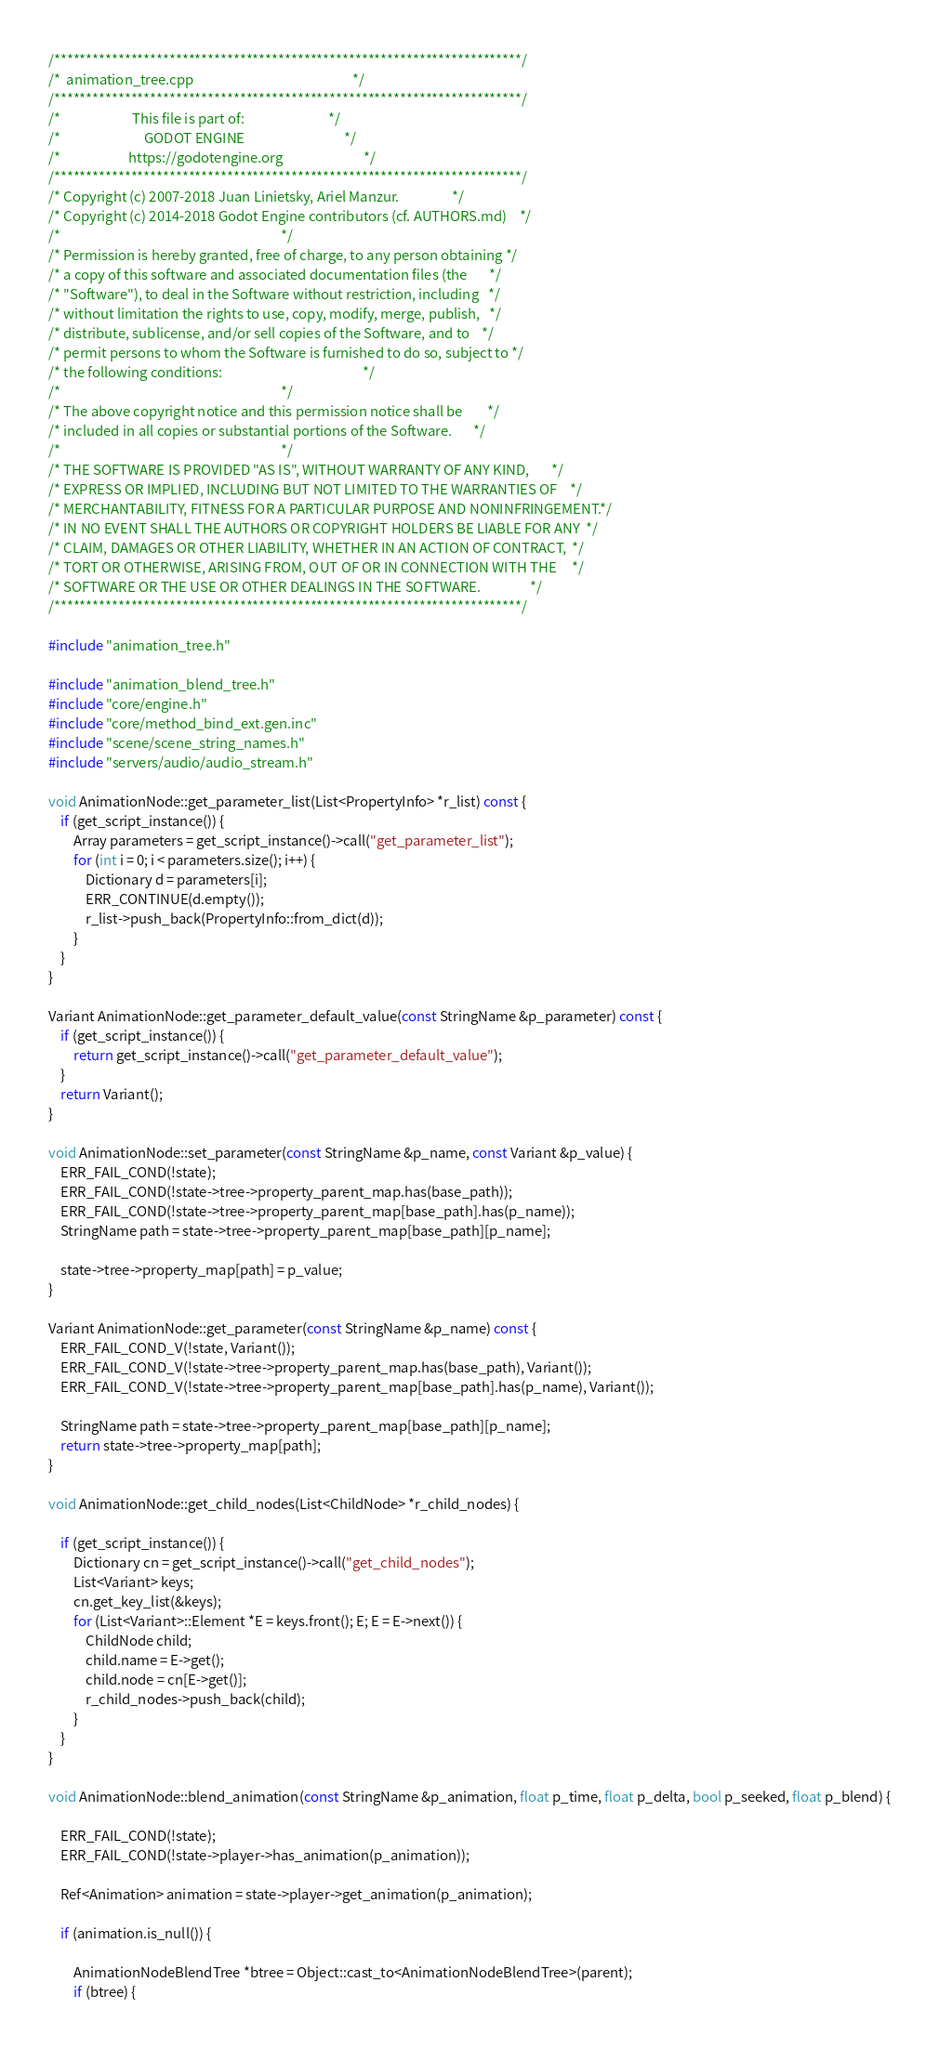<code> <loc_0><loc_0><loc_500><loc_500><_C++_>/*************************************************************************/
/*  animation_tree.cpp                                                   */
/*************************************************************************/
/*                       This file is part of:                           */
/*                           GODOT ENGINE                                */
/*                      https://godotengine.org                          */
/*************************************************************************/
/* Copyright (c) 2007-2018 Juan Linietsky, Ariel Manzur.                 */
/* Copyright (c) 2014-2018 Godot Engine contributors (cf. AUTHORS.md)    */
/*                                                                       */
/* Permission is hereby granted, free of charge, to any person obtaining */
/* a copy of this software and associated documentation files (the       */
/* "Software"), to deal in the Software without restriction, including   */
/* without limitation the rights to use, copy, modify, merge, publish,   */
/* distribute, sublicense, and/or sell copies of the Software, and to    */
/* permit persons to whom the Software is furnished to do so, subject to */
/* the following conditions:                                             */
/*                                                                       */
/* The above copyright notice and this permission notice shall be        */
/* included in all copies or substantial portions of the Software.       */
/*                                                                       */
/* THE SOFTWARE IS PROVIDED "AS IS", WITHOUT WARRANTY OF ANY KIND,       */
/* EXPRESS OR IMPLIED, INCLUDING BUT NOT LIMITED TO THE WARRANTIES OF    */
/* MERCHANTABILITY, FITNESS FOR A PARTICULAR PURPOSE AND NONINFRINGEMENT.*/
/* IN NO EVENT SHALL THE AUTHORS OR COPYRIGHT HOLDERS BE LIABLE FOR ANY  */
/* CLAIM, DAMAGES OR OTHER LIABILITY, WHETHER IN AN ACTION OF CONTRACT,  */
/* TORT OR OTHERWISE, ARISING FROM, OUT OF OR IN CONNECTION WITH THE     */
/* SOFTWARE OR THE USE OR OTHER DEALINGS IN THE SOFTWARE.                */
/*************************************************************************/

#include "animation_tree.h"

#include "animation_blend_tree.h"
#include "core/engine.h"
#include "core/method_bind_ext.gen.inc"
#include "scene/scene_string_names.h"
#include "servers/audio/audio_stream.h"

void AnimationNode::get_parameter_list(List<PropertyInfo> *r_list) const {
	if (get_script_instance()) {
		Array parameters = get_script_instance()->call("get_parameter_list");
		for (int i = 0; i < parameters.size(); i++) {
			Dictionary d = parameters[i];
			ERR_CONTINUE(d.empty());
			r_list->push_back(PropertyInfo::from_dict(d));
		}
	}
}

Variant AnimationNode::get_parameter_default_value(const StringName &p_parameter) const {
	if (get_script_instance()) {
		return get_script_instance()->call("get_parameter_default_value");
	}
	return Variant();
}

void AnimationNode::set_parameter(const StringName &p_name, const Variant &p_value) {
	ERR_FAIL_COND(!state);
	ERR_FAIL_COND(!state->tree->property_parent_map.has(base_path));
	ERR_FAIL_COND(!state->tree->property_parent_map[base_path].has(p_name));
	StringName path = state->tree->property_parent_map[base_path][p_name];

	state->tree->property_map[path] = p_value;
}

Variant AnimationNode::get_parameter(const StringName &p_name) const {
	ERR_FAIL_COND_V(!state, Variant());
	ERR_FAIL_COND_V(!state->tree->property_parent_map.has(base_path), Variant());
	ERR_FAIL_COND_V(!state->tree->property_parent_map[base_path].has(p_name), Variant());

	StringName path = state->tree->property_parent_map[base_path][p_name];
	return state->tree->property_map[path];
}

void AnimationNode::get_child_nodes(List<ChildNode> *r_child_nodes) {

	if (get_script_instance()) {
		Dictionary cn = get_script_instance()->call("get_child_nodes");
		List<Variant> keys;
		cn.get_key_list(&keys);
		for (List<Variant>::Element *E = keys.front(); E; E = E->next()) {
			ChildNode child;
			child.name = E->get();
			child.node = cn[E->get()];
			r_child_nodes->push_back(child);
		}
	}
}

void AnimationNode::blend_animation(const StringName &p_animation, float p_time, float p_delta, bool p_seeked, float p_blend) {

	ERR_FAIL_COND(!state);
	ERR_FAIL_COND(!state->player->has_animation(p_animation));

	Ref<Animation> animation = state->player->get_animation(p_animation);

	if (animation.is_null()) {

		AnimationNodeBlendTree *btree = Object::cast_to<AnimationNodeBlendTree>(parent);
		if (btree) {</code> 